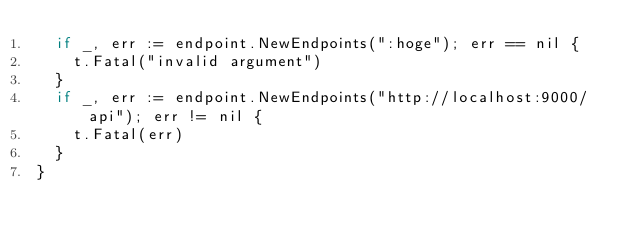Convert code to text. <code><loc_0><loc_0><loc_500><loc_500><_Go_>	if _, err := endpoint.NewEndpoints(":hoge"); err == nil {
		t.Fatal("invalid argument")
	}
	if _, err := endpoint.NewEndpoints("http://localhost:9000/api"); err != nil {
		t.Fatal(err)
	}
}
</code> 